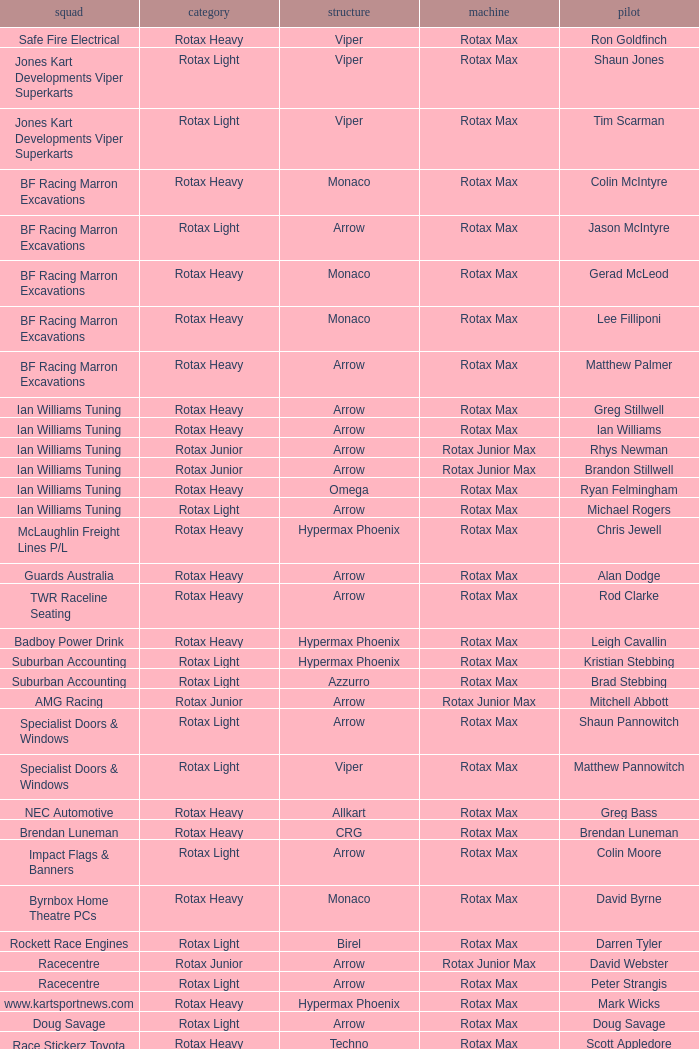Driver Shaun Jones with a viper as a chassis is in what class? Rotax Light. 